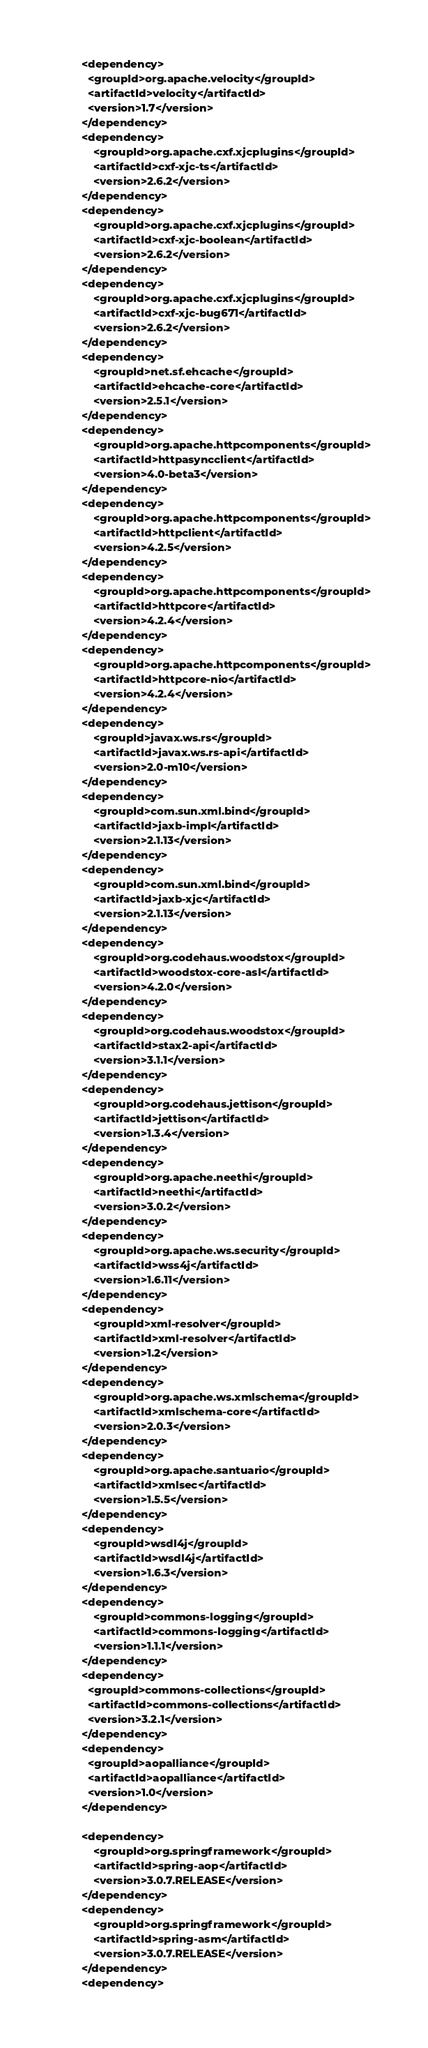<code> <loc_0><loc_0><loc_500><loc_500><_XML_>        <dependency>
          <groupId>org.apache.velocity</groupId>
          <artifactId>velocity</artifactId>
          <version>1.7</version>
        </dependency>
        <dependency>
            <groupId>org.apache.cxf.xjcplugins</groupId>
            <artifactId>cxf-xjc-ts</artifactId>
            <version>2.6.2</version>
        </dependency>
        <dependency>
            <groupId>org.apache.cxf.xjcplugins</groupId>
            <artifactId>cxf-xjc-boolean</artifactId>
            <version>2.6.2</version>
        </dependency>
        <dependency>
            <groupId>org.apache.cxf.xjcplugins</groupId>
            <artifactId>cxf-xjc-bug671</artifactId>
            <version>2.6.2</version>
        </dependency>
        <dependency>
            <groupId>net.sf.ehcache</groupId>
            <artifactId>ehcache-core</artifactId>
            <version>2.5.1</version>
        </dependency>
        <dependency>
            <groupId>org.apache.httpcomponents</groupId>
            <artifactId>httpasyncclient</artifactId>
            <version>4.0-beta3</version>
        </dependency>
        <dependency>
            <groupId>org.apache.httpcomponents</groupId>
            <artifactId>httpclient</artifactId>
            <version>4.2.5</version>
        </dependency>
        <dependency>
            <groupId>org.apache.httpcomponents</groupId>
            <artifactId>httpcore</artifactId>
            <version>4.2.4</version>
        </dependency>
        <dependency>
            <groupId>org.apache.httpcomponents</groupId>
            <artifactId>httpcore-nio</artifactId>
            <version>4.2.4</version>
        </dependency>
        <dependency>
            <groupId>javax.ws.rs</groupId>
            <artifactId>javax.ws.rs-api</artifactId>
            <version>2.0-m10</version>
        </dependency>
        <dependency>
            <groupId>com.sun.xml.bind</groupId>
            <artifactId>jaxb-impl</artifactId>
            <version>2.1.13</version>
        </dependency>
        <dependency>
            <groupId>com.sun.xml.bind</groupId>
            <artifactId>jaxb-xjc</artifactId>
            <version>2.1.13</version>
        </dependency>
        <dependency>
            <groupId>org.codehaus.woodstox</groupId>
            <artifactId>woodstox-core-asl</artifactId>
            <version>4.2.0</version>
        </dependency>
        <dependency>
            <groupId>org.codehaus.woodstox</groupId>
            <artifactId>stax2-api</artifactId>
            <version>3.1.1</version>
        </dependency>
        <dependency>
            <groupId>org.codehaus.jettison</groupId>
            <artifactId>jettison</artifactId>
            <version>1.3.4</version>
        </dependency>
        <dependency>
            <groupId>org.apache.neethi</groupId>
            <artifactId>neethi</artifactId>
            <version>3.0.2</version>
        </dependency>
        <dependency>
            <groupId>org.apache.ws.security</groupId>
            <artifactId>wss4j</artifactId>
            <version>1.6.11</version>
        </dependency>
        <dependency>
            <groupId>xml-resolver</groupId>
            <artifactId>xml-resolver</artifactId>
            <version>1.2</version>
        </dependency>
        <dependency>
            <groupId>org.apache.ws.xmlschema</groupId>
            <artifactId>xmlschema-core</artifactId>
            <version>2.0.3</version>
        </dependency>
        <dependency>
            <groupId>org.apache.santuario</groupId>
            <artifactId>xmlsec</artifactId>
            <version>1.5.5</version>
        </dependency>
        <dependency>
            <groupId>wsdl4j</groupId>
            <artifactId>wsdl4j</artifactId>
            <version>1.6.3</version>
        </dependency>
        <dependency>
            <groupId>commons-logging</groupId>
            <artifactId>commons-logging</artifactId>
            <version>1.1.1</version>
        </dependency>
        <dependency>
          <groupId>commons-collections</groupId>
          <artifactId>commons-collections</artifactId>
          <version>3.2.1</version>
        </dependency>
        <dependency>
          <groupId>aopalliance</groupId>
          <artifactId>aopalliance</artifactId>
          <version>1.0</version>
        </dependency>

        <dependency>
            <groupId>org.springframework</groupId>
            <artifactId>spring-aop</artifactId>
            <version>3.0.7.RELEASE</version>
        </dependency>
        <dependency>
            <groupId>org.springframework</groupId>
            <artifactId>spring-asm</artifactId>
            <version>3.0.7.RELEASE</version>
        </dependency>
        <dependency></code> 